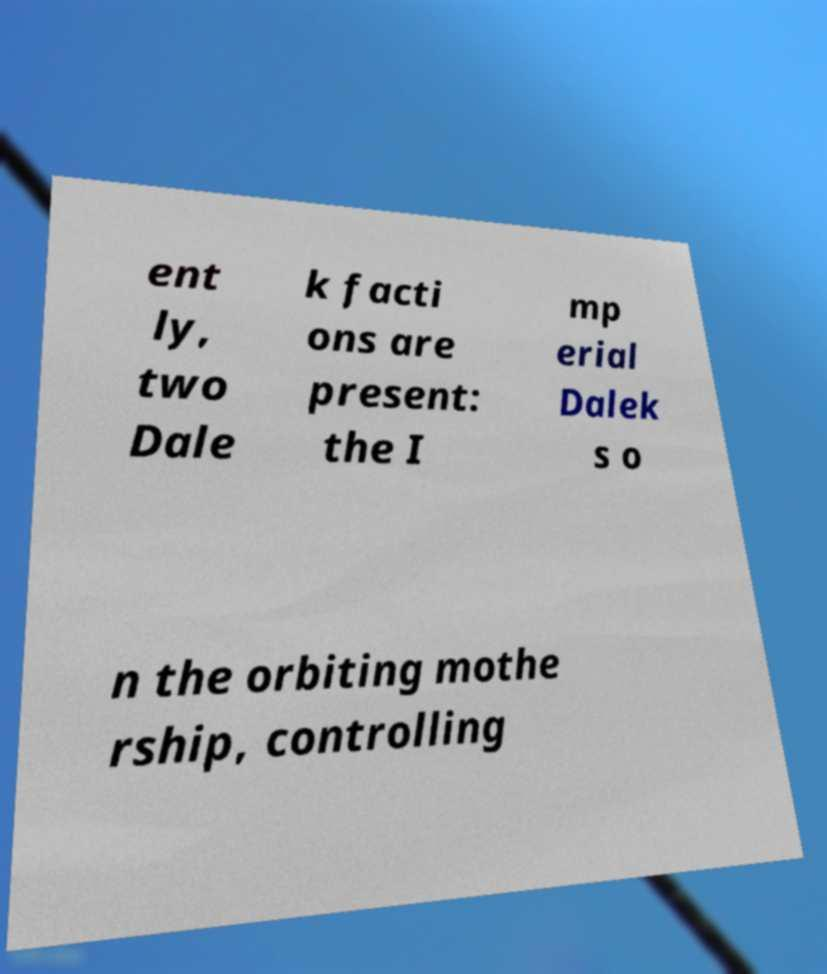Could you extract and type out the text from this image? ent ly, two Dale k facti ons are present: the I mp erial Dalek s o n the orbiting mothe rship, controlling 